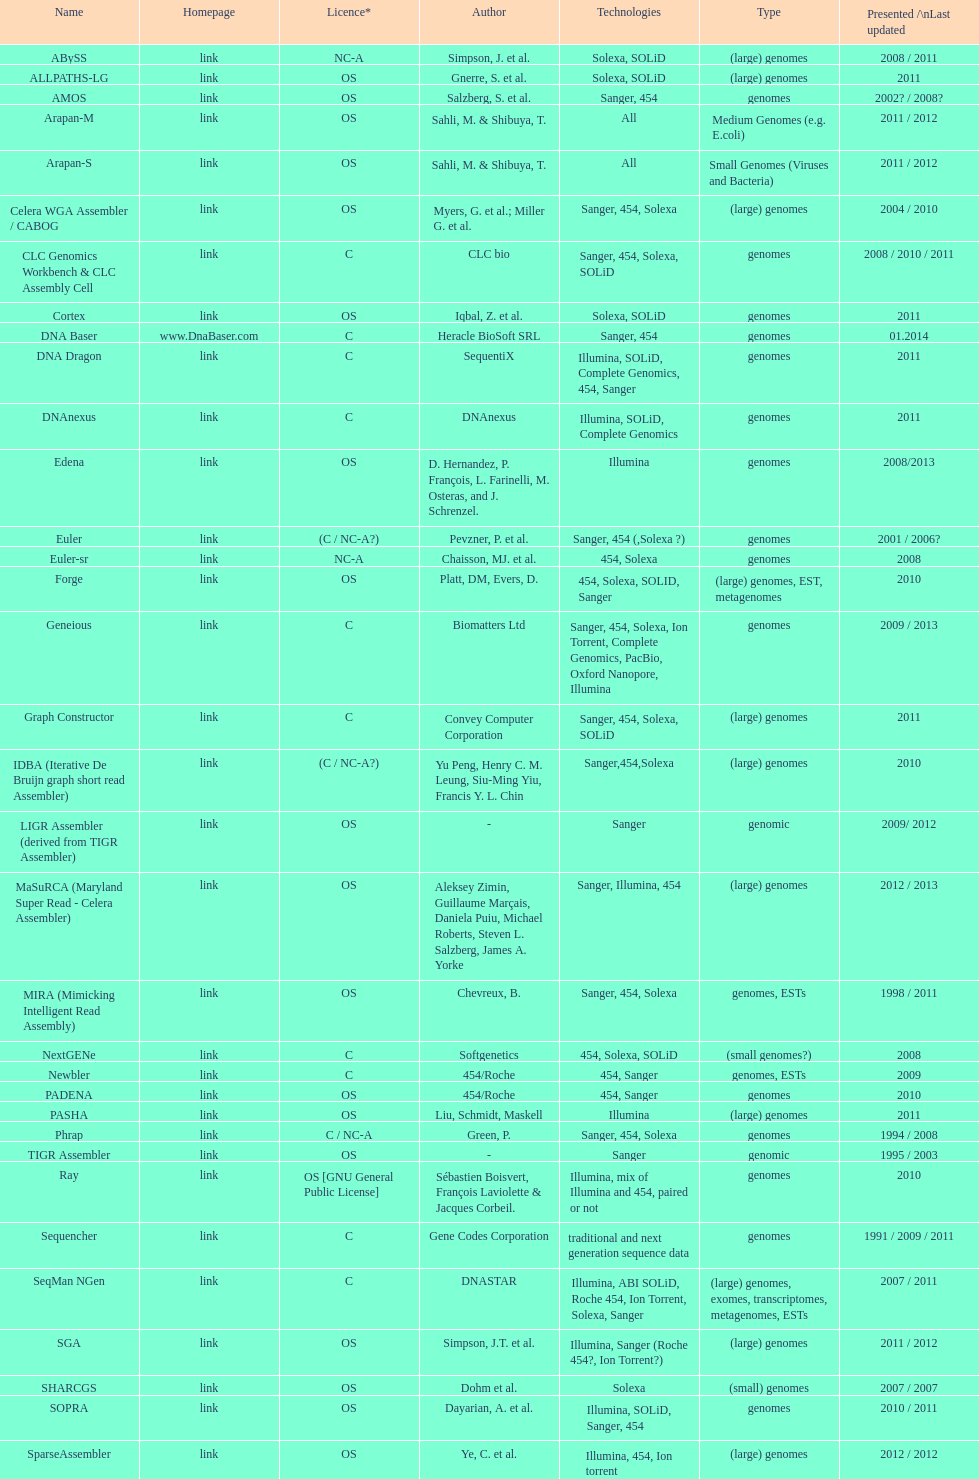What is the newest presentation or updated? DNA Baser. 